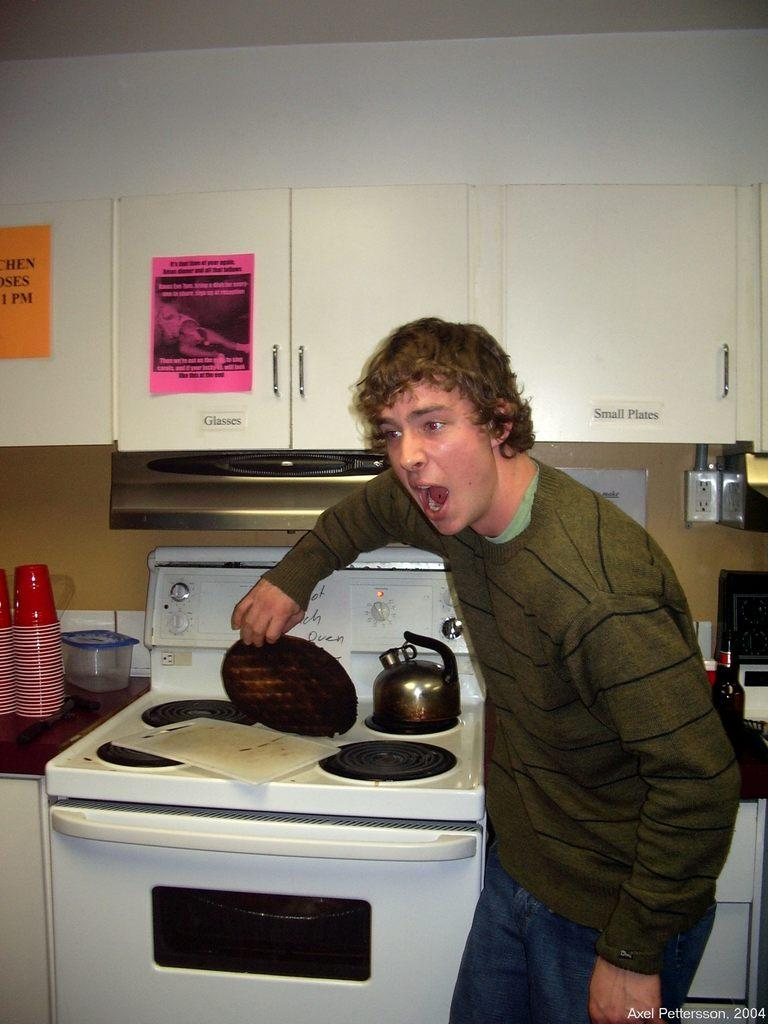<image>
Relay a brief, clear account of the picture shown. A person holding a waffle and a sticker that reads small plates 